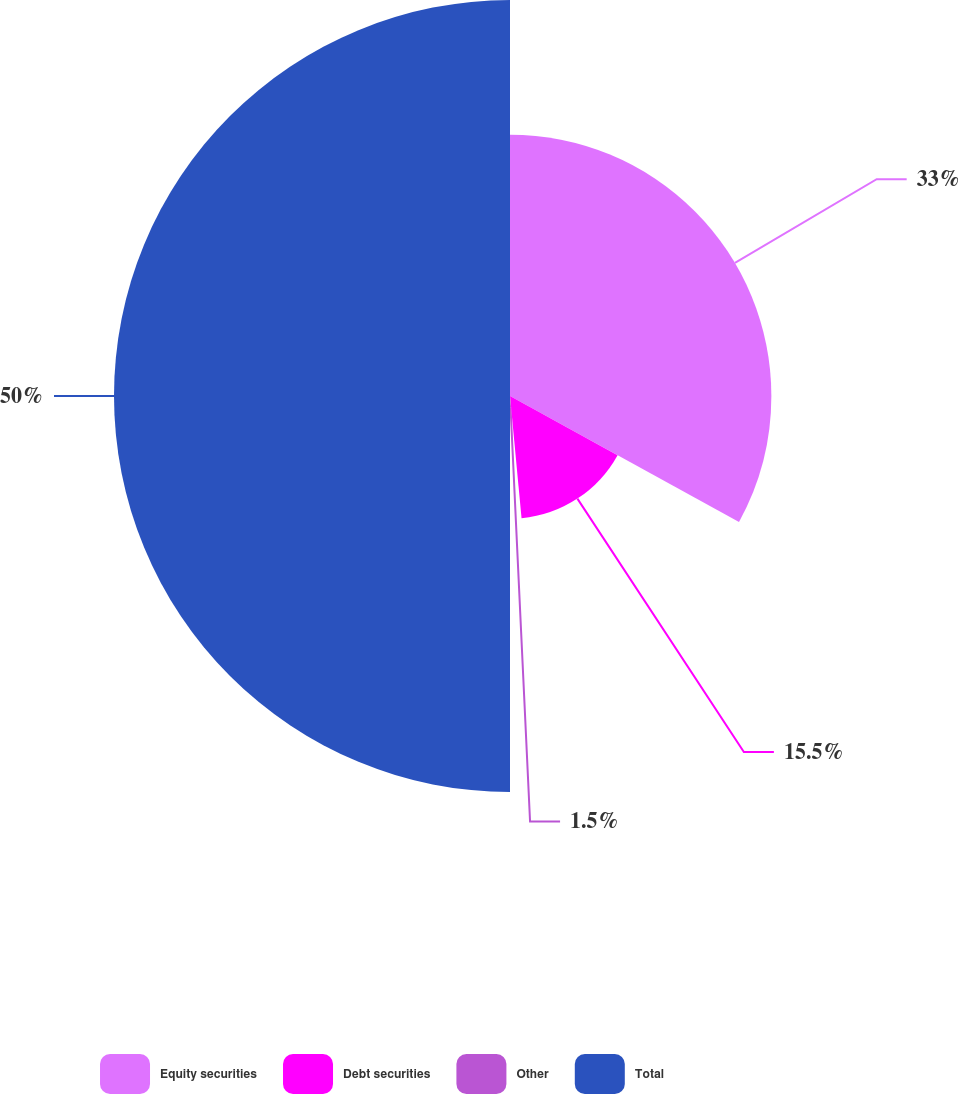Convert chart. <chart><loc_0><loc_0><loc_500><loc_500><pie_chart><fcel>Equity securities<fcel>Debt securities<fcel>Other<fcel>Total<nl><fcel>33.0%<fcel>15.5%<fcel>1.5%<fcel>50.0%<nl></chart> 